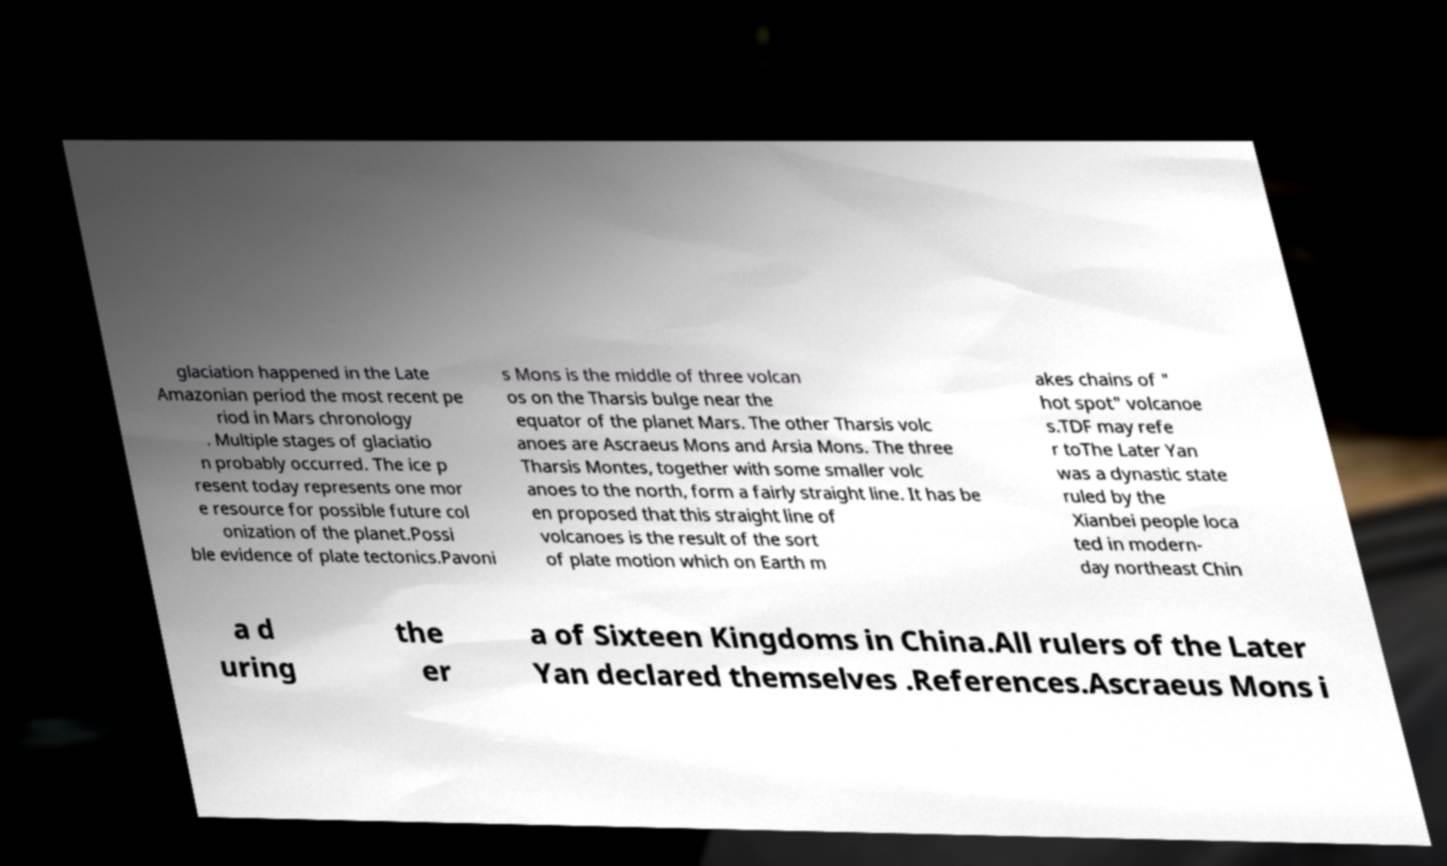Please read and relay the text visible in this image. What does it say? glaciation happened in the Late Amazonian period the most recent pe riod in Mars chronology . Multiple stages of glaciatio n probably occurred. The ice p resent today represents one mor e resource for possible future col onization of the planet.Possi ble evidence of plate tectonics.Pavoni s Mons is the middle of three volcan os on the Tharsis bulge near the equator of the planet Mars. The other Tharsis volc anoes are Ascraeus Mons and Arsia Mons. The three Tharsis Montes, together with some smaller volc anoes to the north, form a fairly straight line. It has be en proposed that this straight line of volcanoes is the result of the sort of plate motion which on Earth m akes chains of " hot spot" volcanoe s.TDF may refe r toThe Later Yan was a dynastic state ruled by the Xianbei people loca ted in modern- day northeast Chin a d uring the er a of Sixteen Kingdoms in China.All rulers of the Later Yan declared themselves .References.Ascraeus Mons i 